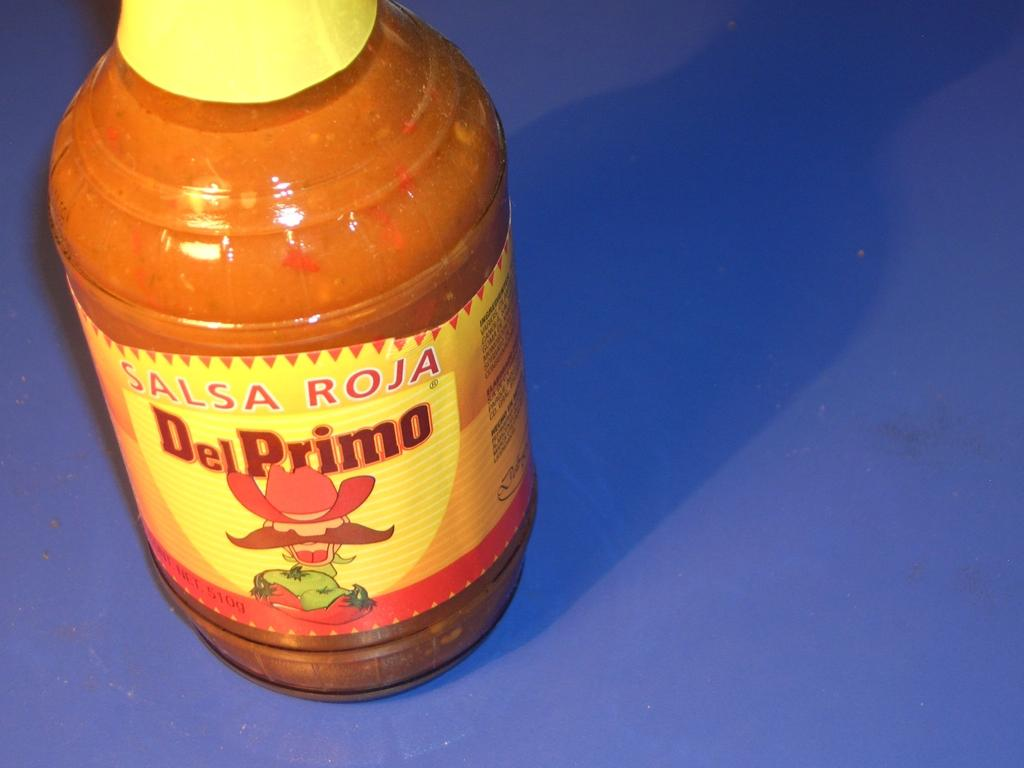<image>
Provide a brief description of the given image. A bottle of Del Primo Salsa Roja alone on a table. 